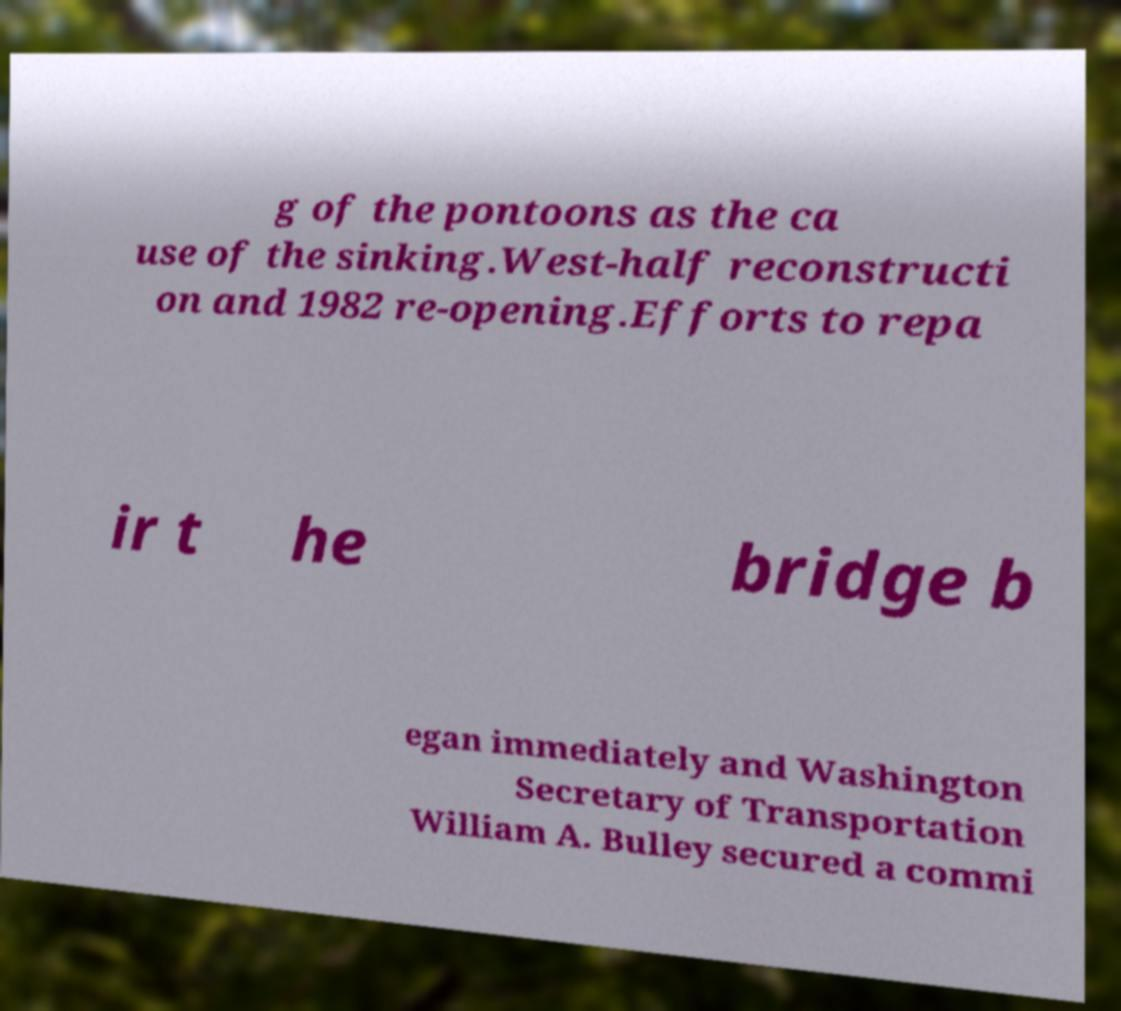For documentation purposes, I need the text within this image transcribed. Could you provide that? g of the pontoons as the ca use of the sinking.West-half reconstructi on and 1982 re-opening.Efforts to repa ir t he bridge b egan immediately and Washington Secretary of Transportation William A. Bulley secured a commi 